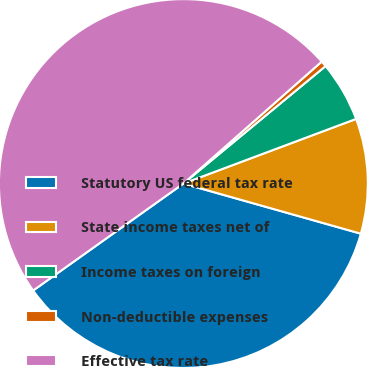<chart> <loc_0><loc_0><loc_500><loc_500><pie_chart><fcel>Statutory US federal tax rate<fcel>State income taxes net of<fcel>Income taxes on foreign<fcel>Non-deductible expenses<fcel>Effective tax rate<nl><fcel>35.77%<fcel>10.08%<fcel>5.29%<fcel>0.51%<fcel>48.34%<nl></chart> 